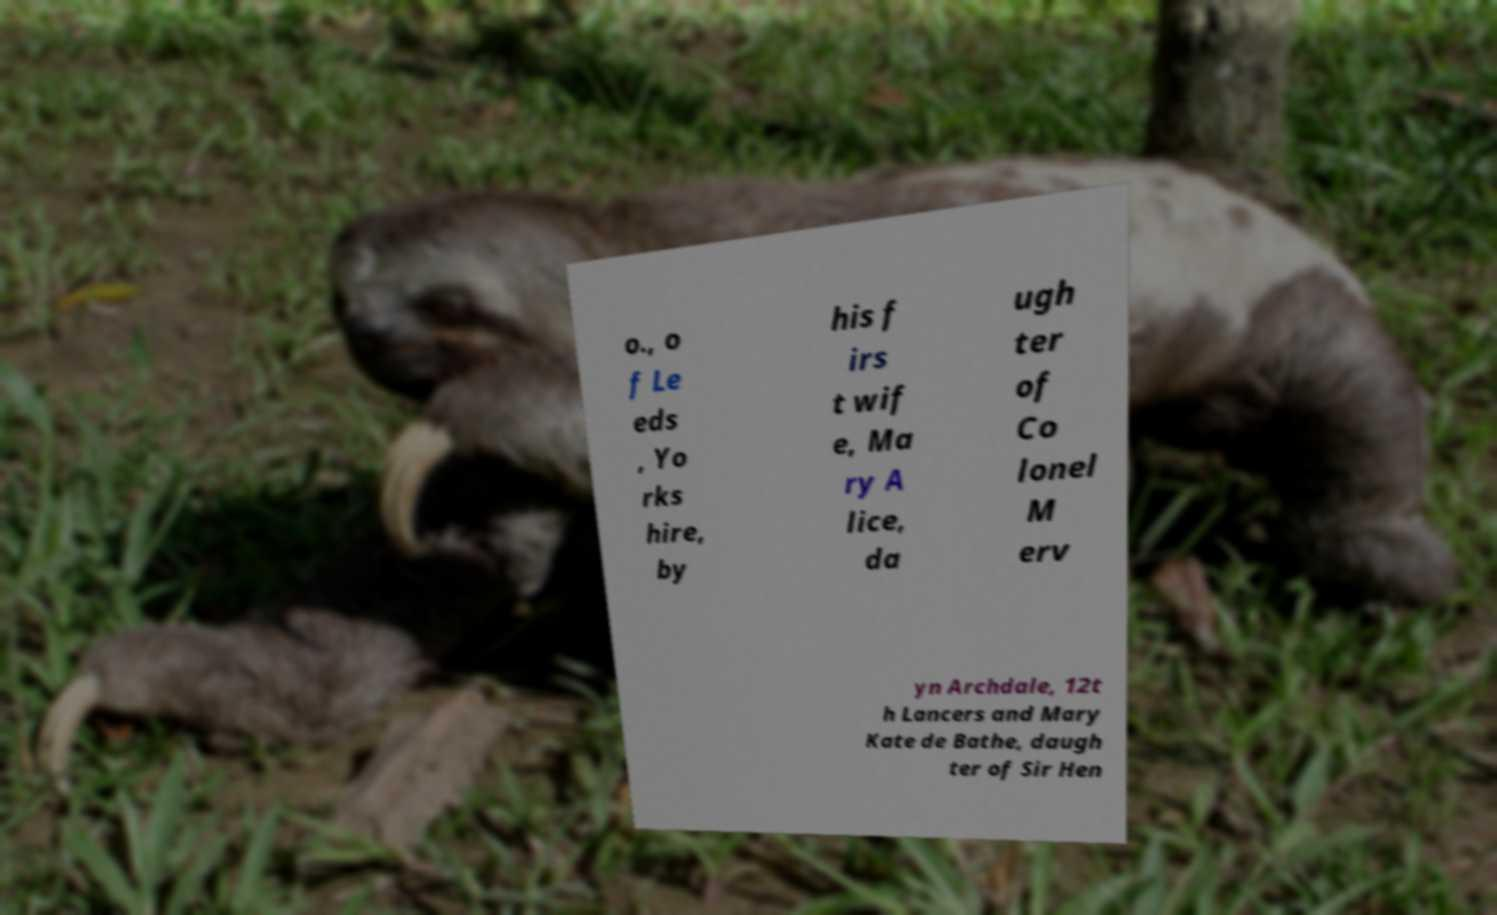Can you read and provide the text displayed in the image?This photo seems to have some interesting text. Can you extract and type it out for me? o., o f Le eds , Yo rks hire, by his f irs t wif e, Ma ry A lice, da ugh ter of Co lonel M erv yn Archdale, 12t h Lancers and Mary Kate de Bathe, daugh ter of Sir Hen 